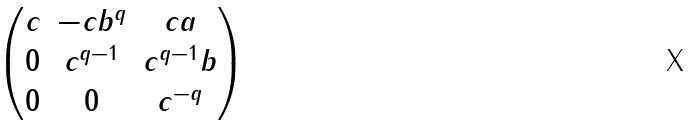<formula> <loc_0><loc_0><loc_500><loc_500>\begin{pmatrix} c & - c b ^ { q } & c a \\ 0 & c ^ { q - 1 } & c ^ { q - 1 } b \\ 0 & 0 & c ^ { - q } \end{pmatrix}</formula> 